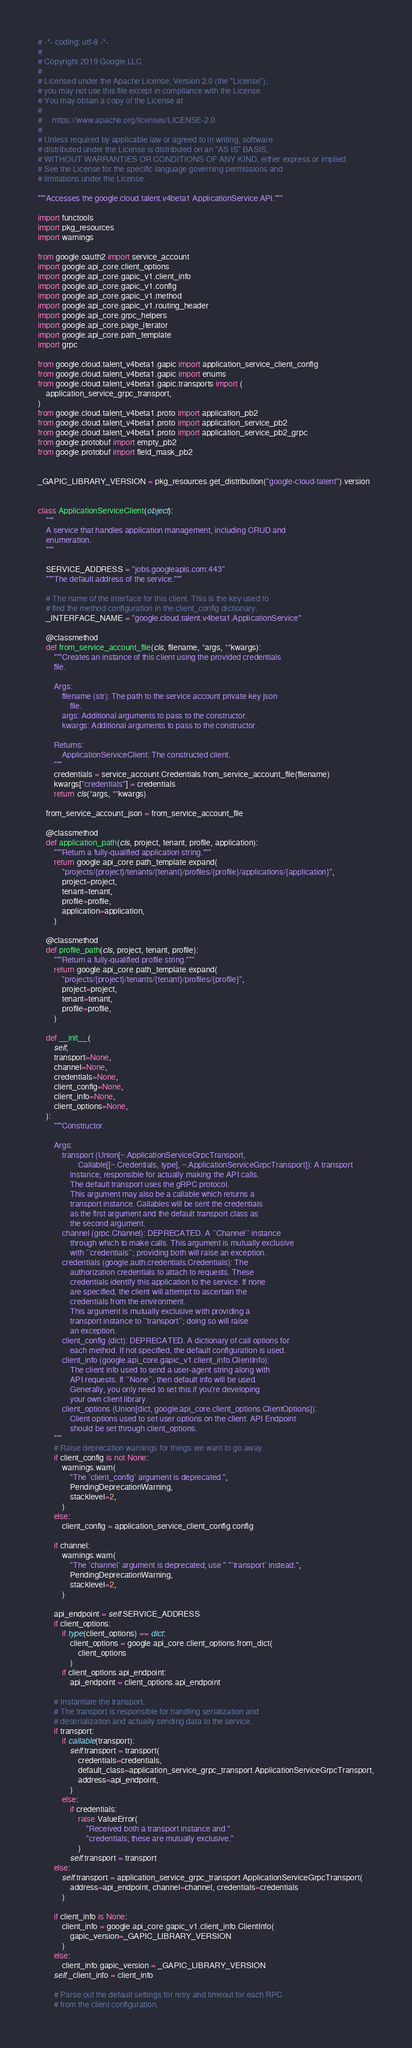<code> <loc_0><loc_0><loc_500><loc_500><_Python_># -*- coding: utf-8 -*-
#
# Copyright 2019 Google LLC
#
# Licensed under the Apache License, Version 2.0 (the "License");
# you may not use this file except in compliance with the License.
# You may obtain a copy of the License at
#
#     https://www.apache.org/licenses/LICENSE-2.0
#
# Unless required by applicable law or agreed to in writing, software
# distributed under the License is distributed on an "AS IS" BASIS,
# WITHOUT WARRANTIES OR CONDITIONS OF ANY KIND, either express or implied.
# See the License for the specific language governing permissions and
# limitations under the License.

"""Accesses the google.cloud.talent.v4beta1 ApplicationService API."""

import functools
import pkg_resources
import warnings

from google.oauth2 import service_account
import google.api_core.client_options
import google.api_core.gapic_v1.client_info
import google.api_core.gapic_v1.config
import google.api_core.gapic_v1.method
import google.api_core.gapic_v1.routing_header
import google.api_core.grpc_helpers
import google.api_core.page_iterator
import google.api_core.path_template
import grpc

from google.cloud.talent_v4beta1.gapic import application_service_client_config
from google.cloud.talent_v4beta1.gapic import enums
from google.cloud.talent_v4beta1.gapic.transports import (
    application_service_grpc_transport,
)
from google.cloud.talent_v4beta1.proto import application_pb2
from google.cloud.talent_v4beta1.proto import application_service_pb2
from google.cloud.talent_v4beta1.proto import application_service_pb2_grpc
from google.protobuf import empty_pb2
from google.protobuf import field_mask_pb2


_GAPIC_LIBRARY_VERSION = pkg_resources.get_distribution("google-cloud-talent").version


class ApplicationServiceClient(object):
    """
    A service that handles application management, including CRUD and
    enumeration.
    """

    SERVICE_ADDRESS = "jobs.googleapis.com:443"
    """The default address of the service."""

    # The name of the interface for this client. This is the key used to
    # find the method configuration in the client_config dictionary.
    _INTERFACE_NAME = "google.cloud.talent.v4beta1.ApplicationService"

    @classmethod
    def from_service_account_file(cls, filename, *args, **kwargs):
        """Creates an instance of this client using the provided credentials
        file.

        Args:
            filename (str): The path to the service account private key json
                file.
            args: Additional arguments to pass to the constructor.
            kwargs: Additional arguments to pass to the constructor.

        Returns:
            ApplicationServiceClient: The constructed client.
        """
        credentials = service_account.Credentials.from_service_account_file(filename)
        kwargs["credentials"] = credentials
        return cls(*args, **kwargs)

    from_service_account_json = from_service_account_file

    @classmethod
    def application_path(cls, project, tenant, profile, application):
        """Return a fully-qualified application string."""
        return google.api_core.path_template.expand(
            "projects/{project}/tenants/{tenant}/profiles/{profile}/applications/{application}",
            project=project,
            tenant=tenant,
            profile=profile,
            application=application,
        )

    @classmethod
    def profile_path(cls, project, tenant, profile):
        """Return a fully-qualified profile string."""
        return google.api_core.path_template.expand(
            "projects/{project}/tenants/{tenant}/profiles/{profile}",
            project=project,
            tenant=tenant,
            profile=profile,
        )

    def __init__(
        self,
        transport=None,
        channel=None,
        credentials=None,
        client_config=None,
        client_info=None,
        client_options=None,
    ):
        """Constructor.

        Args:
            transport (Union[~.ApplicationServiceGrpcTransport,
                    Callable[[~.Credentials, type], ~.ApplicationServiceGrpcTransport]): A transport
                instance, responsible for actually making the API calls.
                The default transport uses the gRPC protocol.
                This argument may also be a callable which returns a
                transport instance. Callables will be sent the credentials
                as the first argument and the default transport class as
                the second argument.
            channel (grpc.Channel): DEPRECATED. A ``Channel`` instance
                through which to make calls. This argument is mutually exclusive
                with ``credentials``; providing both will raise an exception.
            credentials (google.auth.credentials.Credentials): The
                authorization credentials to attach to requests. These
                credentials identify this application to the service. If none
                are specified, the client will attempt to ascertain the
                credentials from the environment.
                This argument is mutually exclusive with providing a
                transport instance to ``transport``; doing so will raise
                an exception.
            client_config (dict): DEPRECATED. A dictionary of call options for
                each method. If not specified, the default configuration is used.
            client_info (google.api_core.gapic_v1.client_info.ClientInfo):
                The client info used to send a user-agent string along with
                API requests. If ``None``, then default info will be used.
                Generally, you only need to set this if you're developing
                your own client library.
            client_options (Union[dict, google.api_core.client_options.ClientOptions]):
                Client options used to set user options on the client. API Endpoint
                should be set through client_options.
        """
        # Raise deprecation warnings for things we want to go away.
        if client_config is not None:
            warnings.warn(
                "The `client_config` argument is deprecated.",
                PendingDeprecationWarning,
                stacklevel=2,
            )
        else:
            client_config = application_service_client_config.config

        if channel:
            warnings.warn(
                "The `channel` argument is deprecated; use " "`transport` instead.",
                PendingDeprecationWarning,
                stacklevel=2,
            )

        api_endpoint = self.SERVICE_ADDRESS
        if client_options:
            if type(client_options) == dict:
                client_options = google.api_core.client_options.from_dict(
                    client_options
                )
            if client_options.api_endpoint:
                api_endpoint = client_options.api_endpoint

        # Instantiate the transport.
        # The transport is responsible for handling serialization and
        # deserialization and actually sending data to the service.
        if transport:
            if callable(transport):
                self.transport = transport(
                    credentials=credentials,
                    default_class=application_service_grpc_transport.ApplicationServiceGrpcTransport,
                    address=api_endpoint,
                )
            else:
                if credentials:
                    raise ValueError(
                        "Received both a transport instance and "
                        "credentials; these are mutually exclusive."
                    )
                self.transport = transport
        else:
            self.transport = application_service_grpc_transport.ApplicationServiceGrpcTransport(
                address=api_endpoint, channel=channel, credentials=credentials
            )

        if client_info is None:
            client_info = google.api_core.gapic_v1.client_info.ClientInfo(
                gapic_version=_GAPIC_LIBRARY_VERSION
            )
        else:
            client_info.gapic_version = _GAPIC_LIBRARY_VERSION
        self._client_info = client_info

        # Parse out the default settings for retry and timeout for each RPC
        # from the client configuration.</code> 